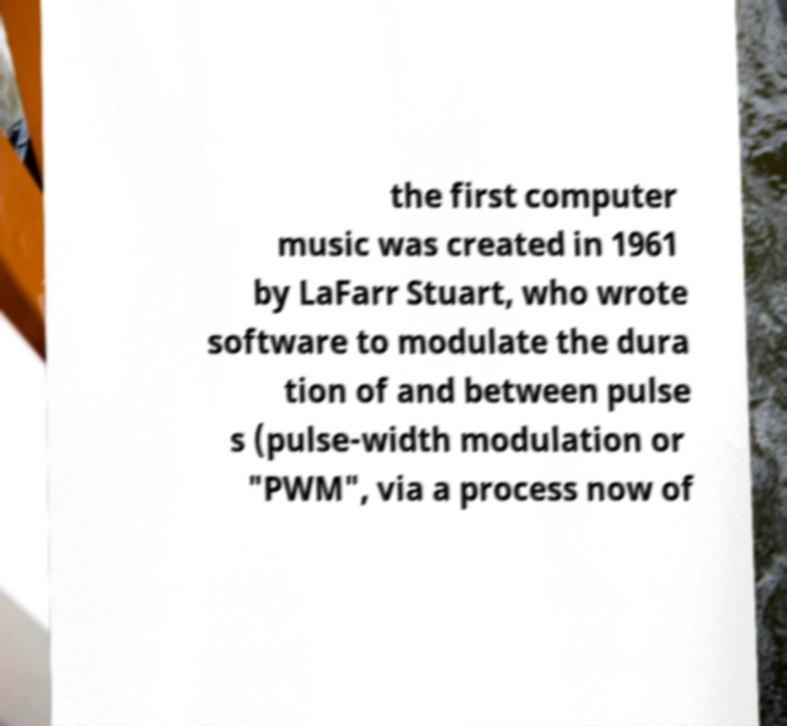Can you accurately transcribe the text from the provided image for me? the first computer music was created in 1961 by LaFarr Stuart, who wrote software to modulate the dura tion of and between pulse s (pulse-width modulation or "PWM", via a process now of 